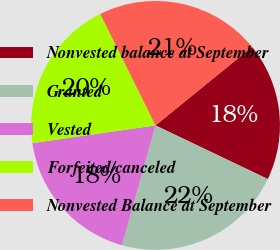<chart> <loc_0><loc_0><loc_500><loc_500><pie_chart><fcel>Nonvested balance at September<fcel>Granted<fcel>Vested<fcel>Forfeited/canceled<fcel>Nonvested Balance at September<nl><fcel>17.96%<fcel>22.25%<fcel>18.38%<fcel>19.95%<fcel>21.46%<nl></chart> 